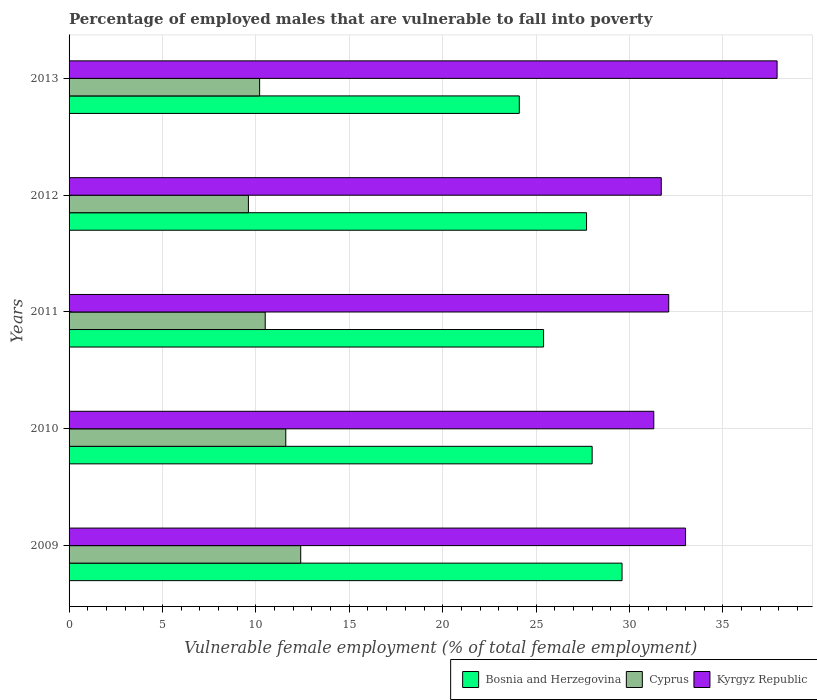Are the number of bars per tick equal to the number of legend labels?
Provide a succinct answer. Yes. How many bars are there on the 1st tick from the top?
Offer a terse response. 3. How many bars are there on the 1st tick from the bottom?
Your answer should be very brief. 3. What is the label of the 3rd group of bars from the top?
Make the answer very short. 2011. What is the percentage of employed males who are vulnerable to fall into poverty in Kyrgyz Republic in 2013?
Give a very brief answer. 37.9. Across all years, what is the maximum percentage of employed males who are vulnerable to fall into poverty in Cyprus?
Offer a terse response. 12.4. Across all years, what is the minimum percentage of employed males who are vulnerable to fall into poverty in Kyrgyz Republic?
Ensure brevity in your answer.  31.3. In which year was the percentage of employed males who are vulnerable to fall into poverty in Kyrgyz Republic minimum?
Your answer should be compact. 2010. What is the total percentage of employed males who are vulnerable to fall into poverty in Kyrgyz Republic in the graph?
Offer a very short reply. 166. What is the difference between the percentage of employed males who are vulnerable to fall into poverty in Bosnia and Herzegovina in 2011 and that in 2012?
Ensure brevity in your answer.  -2.3. What is the difference between the percentage of employed males who are vulnerable to fall into poverty in Bosnia and Herzegovina in 2013 and the percentage of employed males who are vulnerable to fall into poverty in Cyprus in 2012?
Give a very brief answer. 14.5. What is the average percentage of employed males who are vulnerable to fall into poverty in Kyrgyz Republic per year?
Offer a very short reply. 33.2. In the year 2011, what is the difference between the percentage of employed males who are vulnerable to fall into poverty in Kyrgyz Republic and percentage of employed males who are vulnerable to fall into poverty in Bosnia and Herzegovina?
Ensure brevity in your answer.  6.7. What is the ratio of the percentage of employed males who are vulnerable to fall into poverty in Kyrgyz Republic in 2011 to that in 2012?
Provide a short and direct response. 1.01. Is the difference between the percentage of employed males who are vulnerable to fall into poverty in Kyrgyz Republic in 2010 and 2012 greater than the difference between the percentage of employed males who are vulnerable to fall into poverty in Bosnia and Herzegovina in 2010 and 2012?
Offer a terse response. No. What is the difference between the highest and the second highest percentage of employed males who are vulnerable to fall into poverty in Bosnia and Herzegovina?
Offer a terse response. 1.6. What is the difference between the highest and the lowest percentage of employed males who are vulnerable to fall into poverty in Kyrgyz Republic?
Offer a terse response. 6.6. What does the 2nd bar from the top in 2011 represents?
Provide a short and direct response. Cyprus. What does the 1st bar from the bottom in 2009 represents?
Ensure brevity in your answer.  Bosnia and Herzegovina. Is it the case that in every year, the sum of the percentage of employed males who are vulnerable to fall into poverty in Cyprus and percentage of employed males who are vulnerable to fall into poverty in Kyrgyz Republic is greater than the percentage of employed males who are vulnerable to fall into poverty in Bosnia and Herzegovina?
Keep it short and to the point. Yes. Are all the bars in the graph horizontal?
Offer a very short reply. Yes. Are the values on the major ticks of X-axis written in scientific E-notation?
Your response must be concise. No. Where does the legend appear in the graph?
Your answer should be compact. Bottom right. How are the legend labels stacked?
Give a very brief answer. Horizontal. What is the title of the graph?
Make the answer very short. Percentage of employed males that are vulnerable to fall into poverty. What is the label or title of the X-axis?
Provide a short and direct response. Vulnerable female employment (% of total female employment). What is the Vulnerable female employment (% of total female employment) of Bosnia and Herzegovina in 2009?
Keep it short and to the point. 29.6. What is the Vulnerable female employment (% of total female employment) of Cyprus in 2009?
Make the answer very short. 12.4. What is the Vulnerable female employment (% of total female employment) of Kyrgyz Republic in 2009?
Provide a succinct answer. 33. What is the Vulnerable female employment (% of total female employment) of Bosnia and Herzegovina in 2010?
Ensure brevity in your answer.  28. What is the Vulnerable female employment (% of total female employment) in Cyprus in 2010?
Your response must be concise. 11.6. What is the Vulnerable female employment (% of total female employment) in Kyrgyz Republic in 2010?
Provide a short and direct response. 31.3. What is the Vulnerable female employment (% of total female employment) in Bosnia and Herzegovina in 2011?
Keep it short and to the point. 25.4. What is the Vulnerable female employment (% of total female employment) in Cyprus in 2011?
Make the answer very short. 10.5. What is the Vulnerable female employment (% of total female employment) of Kyrgyz Republic in 2011?
Keep it short and to the point. 32.1. What is the Vulnerable female employment (% of total female employment) in Bosnia and Herzegovina in 2012?
Keep it short and to the point. 27.7. What is the Vulnerable female employment (% of total female employment) in Cyprus in 2012?
Your answer should be very brief. 9.6. What is the Vulnerable female employment (% of total female employment) in Kyrgyz Republic in 2012?
Your answer should be compact. 31.7. What is the Vulnerable female employment (% of total female employment) in Bosnia and Herzegovina in 2013?
Give a very brief answer. 24.1. What is the Vulnerable female employment (% of total female employment) in Cyprus in 2013?
Your answer should be very brief. 10.2. What is the Vulnerable female employment (% of total female employment) of Kyrgyz Republic in 2013?
Your answer should be very brief. 37.9. Across all years, what is the maximum Vulnerable female employment (% of total female employment) of Bosnia and Herzegovina?
Ensure brevity in your answer.  29.6. Across all years, what is the maximum Vulnerable female employment (% of total female employment) in Cyprus?
Give a very brief answer. 12.4. Across all years, what is the maximum Vulnerable female employment (% of total female employment) in Kyrgyz Republic?
Ensure brevity in your answer.  37.9. Across all years, what is the minimum Vulnerable female employment (% of total female employment) in Bosnia and Herzegovina?
Provide a succinct answer. 24.1. Across all years, what is the minimum Vulnerable female employment (% of total female employment) in Cyprus?
Keep it short and to the point. 9.6. Across all years, what is the minimum Vulnerable female employment (% of total female employment) of Kyrgyz Republic?
Offer a very short reply. 31.3. What is the total Vulnerable female employment (% of total female employment) in Bosnia and Herzegovina in the graph?
Provide a short and direct response. 134.8. What is the total Vulnerable female employment (% of total female employment) in Cyprus in the graph?
Provide a succinct answer. 54.3. What is the total Vulnerable female employment (% of total female employment) of Kyrgyz Republic in the graph?
Provide a succinct answer. 166. What is the difference between the Vulnerable female employment (% of total female employment) of Bosnia and Herzegovina in 2009 and that in 2011?
Provide a short and direct response. 4.2. What is the difference between the Vulnerable female employment (% of total female employment) of Kyrgyz Republic in 2009 and that in 2012?
Your response must be concise. 1.3. What is the difference between the Vulnerable female employment (% of total female employment) in Cyprus in 2009 and that in 2013?
Your response must be concise. 2.2. What is the difference between the Vulnerable female employment (% of total female employment) of Bosnia and Herzegovina in 2010 and that in 2011?
Offer a terse response. 2.6. What is the difference between the Vulnerable female employment (% of total female employment) of Cyprus in 2010 and that in 2011?
Provide a succinct answer. 1.1. What is the difference between the Vulnerable female employment (% of total female employment) in Kyrgyz Republic in 2010 and that in 2011?
Your answer should be very brief. -0.8. What is the difference between the Vulnerable female employment (% of total female employment) of Cyprus in 2010 and that in 2012?
Provide a succinct answer. 2. What is the difference between the Vulnerable female employment (% of total female employment) of Kyrgyz Republic in 2010 and that in 2012?
Provide a succinct answer. -0.4. What is the difference between the Vulnerable female employment (% of total female employment) in Bosnia and Herzegovina in 2010 and that in 2013?
Provide a short and direct response. 3.9. What is the difference between the Vulnerable female employment (% of total female employment) in Bosnia and Herzegovina in 2012 and that in 2013?
Your answer should be very brief. 3.6. What is the difference between the Vulnerable female employment (% of total female employment) of Cyprus in 2012 and that in 2013?
Keep it short and to the point. -0.6. What is the difference between the Vulnerable female employment (% of total female employment) in Kyrgyz Republic in 2012 and that in 2013?
Offer a terse response. -6.2. What is the difference between the Vulnerable female employment (% of total female employment) of Bosnia and Herzegovina in 2009 and the Vulnerable female employment (% of total female employment) of Cyprus in 2010?
Offer a terse response. 18. What is the difference between the Vulnerable female employment (% of total female employment) of Cyprus in 2009 and the Vulnerable female employment (% of total female employment) of Kyrgyz Republic in 2010?
Offer a very short reply. -18.9. What is the difference between the Vulnerable female employment (% of total female employment) of Cyprus in 2009 and the Vulnerable female employment (% of total female employment) of Kyrgyz Republic in 2011?
Your response must be concise. -19.7. What is the difference between the Vulnerable female employment (% of total female employment) of Cyprus in 2009 and the Vulnerable female employment (% of total female employment) of Kyrgyz Republic in 2012?
Offer a very short reply. -19.3. What is the difference between the Vulnerable female employment (% of total female employment) in Bosnia and Herzegovina in 2009 and the Vulnerable female employment (% of total female employment) in Cyprus in 2013?
Offer a very short reply. 19.4. What is the difference between the Vulnerable female employment (% of total female employment) in Bosnia and Herzegovina in 2009 and the Vulnerable female employment (% of total female employment) in Kyrgyz Republic in 2013?
Make the answer very short. -8.3. What is the difference between the Vulnerable female employment (% of total female employment) in Cyprus in 2009 and the Vulnerable female employment (% of total female employment) in Kyrgyz Republic in 2013?
Your answer should be compact. -25.5. What is the difference between the Vulnerable female employment (% of total female employment) of Bosnia and Herzegovina in 2010 and the Vulnerable female employment (% of total female employment) of Kyrgyz Republic in 2011?
Your response must be concise. -4.1. What is the difference between the Vulnerable female employment (% of total female employment) in Cyprus in 2010 and the Vulnerable female employment (% of total female employment) in Kyrgyz Republic in 2011?
Offer a very short reply. -20.5. What is the difference between the Vulnerable female employment (% of total female employment) of Bosnia and Herzegovina in 2010 and the Vulnerable female employment (% of total female employment) of Cyprus in 2012?
Keep it short and to the point. 18.4. What is the difference between the Vulnerable female employment (% of total female employment) of Bosnia and Herzegovina in 2010 and the Vulnerable female employment (% of total female employment) of Kyrgyz Republic in 2012?
Provide a succinct answer. -3.7. What is the difference between the Vulnerable female employment (% of total female employment) in Cyprus in 2010 and the Vulnerable female employment (% of total female employment) in Kyrgyz Republic in 2012?
Your answer should be compact. -20.1. What is the difference between the Vulnerable female employment (% of total female employment) in Bosnia and Herzegovina in 2010 and the Vulnerable female employment (% of total female employment) in Cyprus in 2013?
Your answer should be compact. 17.8. What is the difference between the Vulnerable female employment (% of total female employment) in Bosnia and Herzegovina in 2010 and the Vulnerable female employment (% of total female employment) in Kyrgyz Republic in 2013?
Provide a short and direct response. -9.9. What is the difference between the Vulnerable female employment (% of total female employment) of Cyprus in 2010 and the Vulnerable female employment (% of total female employment) of Kyrgyz Republic in 2013?
Keep it short and to the point. -26.3. What is the difference between the Vulnerable female employment (% of total female employment) in Bosnia and Herzegovina in 2011 and the Vulnerable female employment (% of total female employment) in Kyrgyz Republic in 2012?
Ensure brevity in your answer.  -6.3. What is the difference between the Vulnerable female employment (% of total female employment) in Cyprus in 2011 and the Vulnerable female employment (% of total female employment) in Kyrgyz Republic in 2012?
Your response must be concise. -21.2. What is the difference between the Vulnerable female employment (% of total female employment) in Cyprus in 2011 and the Vulnerable female employment (% of total female employment) in Kyrgyz Republic in 2013?
Give a very brief answer. -27.4. What is the difference between the Vulnerable female employment (% of total female employment) of Bosnia and Herzegovina in 2012 and the Vulnerable female employment (% of total female employment) of Cyprus in 2013?
Offer a very short reply. 17.5. What is the difference between the Vulnerable female employment (% of total female employment) of Bosnia and Herzegovina in 2012 and the Vulnerable female employment (% of total female employment) of Kyrgyz Republic in 2013?
Offer a terse response. -10.2. What is the difference between the Vulnerable female employment (% of total female employment) of Cyprus in 2012 and the Vulnerable female employment (% of total female employment) of Kyrgyz Republic in 2013?
Give a very brief answer. -28.3. What is the average Vulnerable female employment (% of total female employment) in Bosnia and Herzegovina per year?
Provide a short and direct response. 26.96. What is the average Vulnerable female employment (% of total female employment) in Cyprus per year?
Keep it short and to the point. 10.86. What is the average Vulnerable female employment (% of total female employment) of Kyrgyz Republic per year?
Keep it short and to the point. 33.2. In the year 2009, what is the difference between the Vulnerable female employment (% of total female employment) of Bosnia and Herzegovina and Vulnerable female employment (% of total female employment) of Cyprus?
Your answer should be very brief. 17.2. In the year 2009, what is the difference between the Vulnerable female employment (% of total female employment) of Cyprus and Vulnerable female employment (% of total female employment) of Kyrgyz Republic?
Ensure brevity in your answer.  -20.6. In the year 2010, what is the difference between the Vulnerable female employment (% of total female employment) of Cyprus and Vulnerable female employment (% of total female employment) of Kyrgyz Republic?
Provide a short and direct response. -19.7. In the year 2011, what is the difference between the Vulnerable female employment (% of total female employment) in Bosnia and Herzegovina and Vulnerable female employment (% of total female employment) in Cyprus?
Offer a very short reply. 14.9. In the year 2011, what is the difference between the Vulnerable female employment (% of total female employment) of Bosnia and Herzegovina and Vulnerable female employment (% of total female employment) of Kyrgyz Republic?
Your answer should be very brief. -6.7. In the year 2011, what is the difference between the Vulnerable female employment (% of total female employment) of Cyprus and Vulnerable female employment (% of total female employment) of Kyrgyz Republic?
Make the answer very short. -21.6. In the year 2012, what is the difference between the Vulnerable female employment (% of total female employment) in Bosnia and Herzegovina and Vulnerable female employment (% of total female employment) in Cyprus?
Make the answer very short. 18.1. In the year 2012, what is the difference between the Vulnerable female employment (% of total female employment) of Cyprus and Vulnerable female employment (% of total female employment) of Kyrgyz Republic?
Your response must be concise. -22.1. In the year 2013, what is the difference between the Vulnerable female employment (% of total female employment) of Bosnia and Herzegovina and Vulnerable female employment (% of total female employment) of Cyprus?
Give a very brief answer. 13.9. In the year 2013, what is the difference between the Vulnerable female employment (% of total female employment) of Bosnia and Herzegovina and Vulnerable female employment (% of total female employment) of Kyrgyz Republic?
Offer a terse response. -13.8. In the year 2013, what is the difference between the Vulnerable female employment (% of total female employment) of Cyprus and Vulnerable female employment (% of total female employment) of Kyrgyz Republic?
Provide a short and direct response. -27.7. What is the ratio of the Vulnerable female employment (% of total female employment) of Bosnia and Herzegovina in 2009 to that in 2010?
Your answer should be very brief. 1.06. What is the ratio of the Vulnerable female employment (% of total female employment) in Cyprus in 2009 to that in 2010?
Keep it short and to the point. 1.07. What is the ratio of the Vulnerable female employment (% of total female employment) in Kyrgyz Republic in 2009 to that in 2010?
Your answer should be compact. 1.05. What is the ratio of the Vulnerable female employment (% of total female employment) of Bosnia and Herzegovina in 2009 to that in 2011?
Your response must be concise. 1.17. What is the ratio of the Vulnerable female employment (% of total female employment) of Cyprus in 2009 to that in 2011?
Offer a very short reply. 1.18. What is the ratio of the Vulnerable female employment (% of total female employment) of Kyrgyz Republic in 2009 to that in 2011?
Your answer should be very brief. 1.03. What is the ratio of the Vulnerable female employment (% of total female employment) in Bosnia and Herzegovina in 2009 to that in 2012?
Your response must be concise. 1.07. What is the ratio of the Vulnerable female employment (% of total female employment) of Cyprus in 2009 to that in 2012?
Offer a very short reply. 1.29. What is the ratio of the Vulnerable female employment (% of total female employment) of Kyrgyz Republic in 2009 to that in 2012?
Ensure brevity in your answer.  1.04. What is the ratio of the Vulnerable female employment (% of total female employment) in Bosnia and Herzegovina in 2009 to that in 2013?
Provide a succinct answer. 1.23. What is the ratio of the Vulnerable female employment (% of total female employment) in Cyprus in 2009 to that in 2013?
Offer a terse response. 1.22. What is the ratio of the Vulnerable female employment (% of total female employment) of Kyrgyz Republic in 2009 to that in 2013?
Make the answer very short. 0.87. What is the ratio of the Vulnerable female employment (% of total female employment) of Bosnia and Herzegovina in 2010 to that in 2011?
Keep it short and to the point. 1.1. What is the ratio of the Vulnerable female employment (% of total female employment) of Cyprus in 2010 to that in 2011?
Your response must be concise. 1.1. What is the ratio of the Vulnerable female employment (% of total female employment) of Kyrgyz Republic in 2010 to that in 2011?
Provide a short and direct response. 0.98. What is the ratio of the Vulnerable female employment (% of total female employment) of Bosnia and Herzegovina in 2010 to that in 2012?
Provide a short and direct response. 1.01. What is the ratio of the Vulnerable female employment (% of total female employment) in Cyprus in 2010 to that in 2012?
Your answer should be very brief. 1.21. What is the ratio of the Vulnerable female employment (% of total female employment) of Kyrgyz Republic in 2010 to that in 2012?
Give a very brief answer. 0.99. What is the ratio of the Vulnerable female employment (% of total female employment) of Bosnia and Herzegovina in 2010 to that in 2013?
Make the answer very short. 1.16. What is the ratio of the Vulnerable female employment (% of total female employment) of Cyprus in 2010 to that in 2013?
Your answer should be very brief. 1.14. What is the ratio of the Vulnerable female employment (% of total female employment) in Kyrgyz Republic in 2010 to that in 2013?
Make the answer very short. 0.83. What is the ratio of the Vulnerable female employment (% of total female employment) of Bosnia and Herzegovina in 2011 to that in 2012?
Keep it short and to the point. 0.92. What is the ratio of the Vulnerable female employment (% of total female employment) in Cyprus in 2011 to that in 2012?
Provide a succinct answer. 1.09. What is the ratio of the Vulnerable female employment (% of total female employment) of Kyrgyz Republic in 2011 to that in 2012?
Provide a succinct answer. 1.01. What is the ratio of the Vulnerable female employment (% of total female employment) in Bosnia and Herzegovina in 2011 to that in 2013?
Ensure brevity in your answer.  1.05. What is the ratio of the Vulnerable female employment (% of total female employment) in Cyprus in 2011 to that in 2013?
Make the answer very short. 1.03. What is the ratio of the Vulnerable female employment (% of total female employment) of Kyrgyz Republic in 2011 to that in 2013?
Offer a very short reply. 0.85. What is the ratio of the Vulnerable female employment (% of total female employment) of Bosnia and Herzegovina in 2012 to that in 2013?
Your response must be concise. 1.15. What is the ratio of the Vulnerable female employment (% of total female employment) in Cyprus in 2012 to that in 2013?
Give a very brief answer. 0.94. What is the ratio of the Vulnerable female employment (% of total female employment) in Kyrgyz Republic in 2012 to that in 2013?
Provide a succinct answer. 0.84. What is the difference between the highest and the second highest Vulnerable female employment (% of total female employment) of Cyprus?
Provide a succinct answer. 0.8. What is the difference between the highest and the second highest Vulnerable female employment (% of total female employment) in Kyrgyz Republic?
Your answer should be compact. 4.9. What is the difference between the highest and the lowest Vulnerable female employment (% of total female employment) of Kyrgyz Republic?
Ensure brevity in your answer.  6.6. 